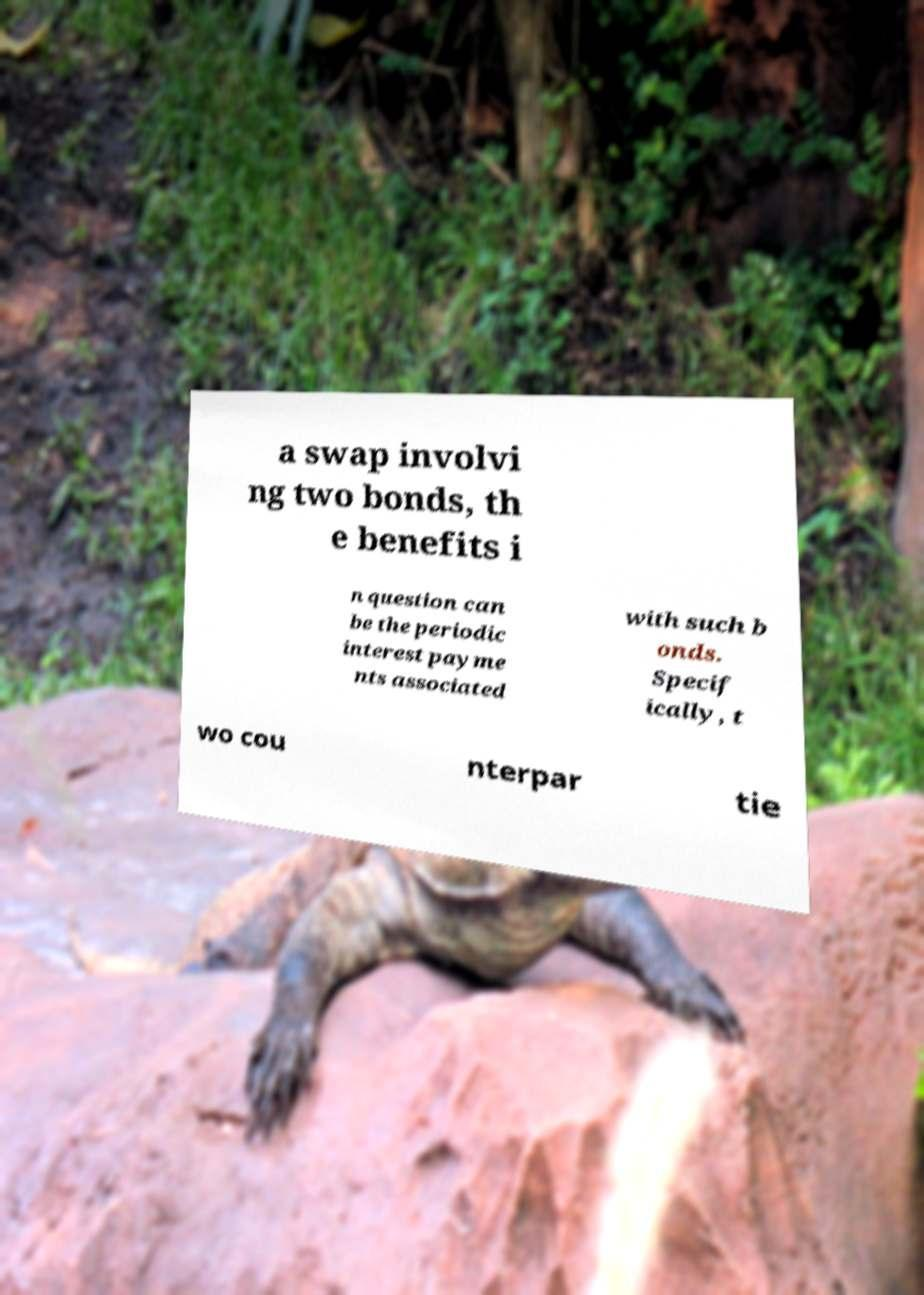I need the written content from this picture converted into text. Can you do that? a swap involvi ng two bonds, th e benefits i n question can be the periodic interest payme nts associated with such b onds. Specif ically, t wo cou nterpar tie 